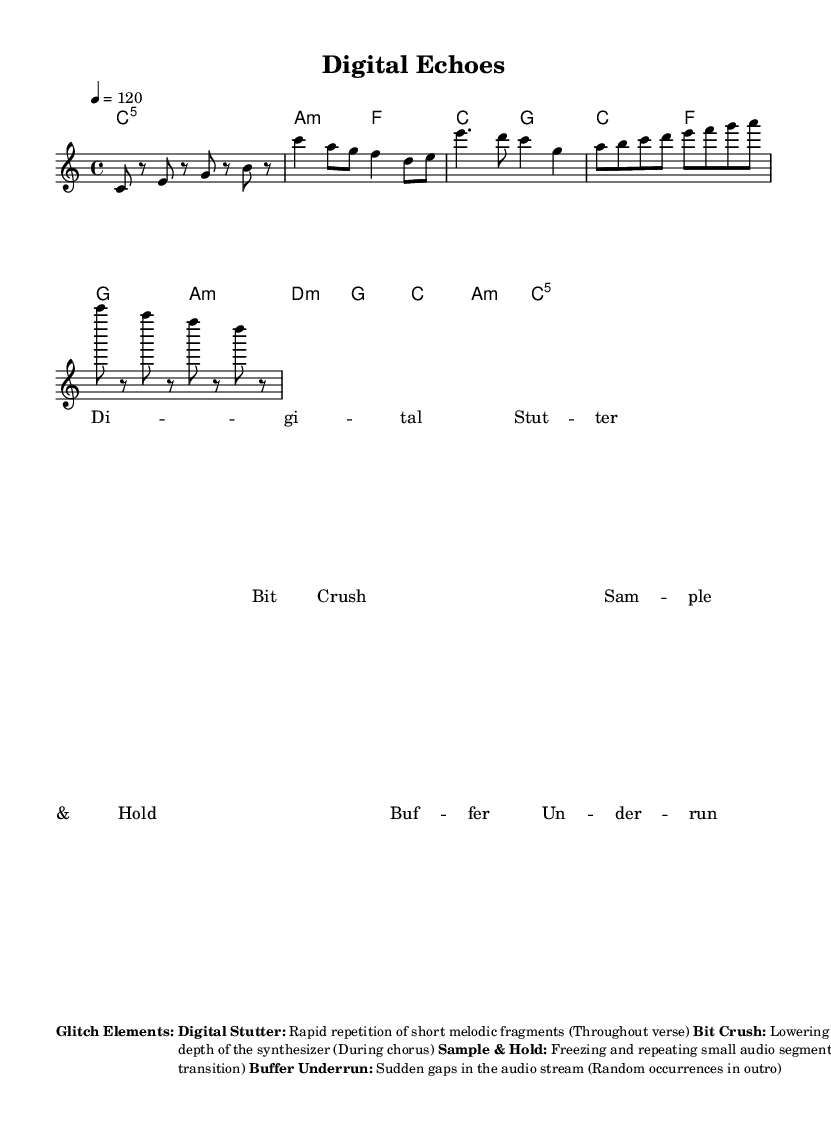What is the key signature of this music? The key signature is C major, which has no sharps or flats.
Answer: C major What is the time signature of this composition? The time signature indicated in the code is 4/4, meaning there are four beats in a measure.
Answer: 4/4 What is the tempo marking given in the score? The tempo is set at 120 beats per minute, indicated as "4 = 120".
Answer: 120 Name one of the glitch elements used in the composition. The composition incorporates elements like "Digital Stutter," "Bit Crush," "Sample & Hold," and "Buffer Underrun" as indicated in the markup section.
Answer: Digital Stutter How many measures are in the Intro section of the melody? The Intro consists of four quarter-note measures making it easy to identify by counting the measures.
Answer: 4 What effect is used during the Chorus? The "Bit Crush" effect is applied during the Chorus to lower the bit depth of the synthesizer sound, enhancing the glitch aesthetic.
Answer: Bit Crush What is the purpose of the "Special Instructions" in the markup? The special instructions indicate to incorporate sudden pitch shifts and tempo glitches, which relate directly to the experimental genre and create a sense of digital errors.
Answer: To emulate computer errors 